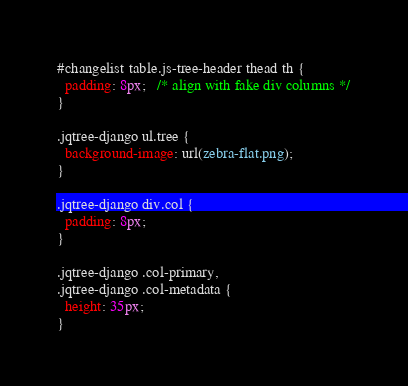Convert code to text. <code><loc_0><loc_0><loc_500><loc_500><_CSS_>#changelist table.js-tree-header thead th {
  padding: 8px;   /* align with fake div columns */
}

.jqtree-django ul.tree {
  background-image: url(zebra-flat.png);
}

.jqtree-django div.col {
  padding: 8px;
}

.jqtree-django .col-primary,
.jqtree-django .col-metadata {
  height: 35px;
}
</code> 